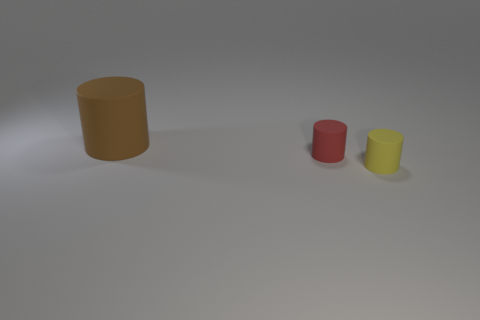Subtract all small rubber cylinders. How many cylinders are left? 1 Add 1 yellow matte cylinders. How many objects exist? 4 Subtract all red cylinders. How many cylinders are left? 2 Subtract 0 cyan cylinders. How many objects are left? 3 Subtract 3 cylinders. How many cylinders are left? 0 Subtract all green cylinders. Subtract all purple cubes. How many cylinders are left? 3 Subtract all large brown cylinders. Subtract all yellow cylinders. How many objects are left? 1 Add 1 red rubber objects. How many red rubber objects are left? 2 Add 2 small cylinders. How many small cylinders exist? 4 